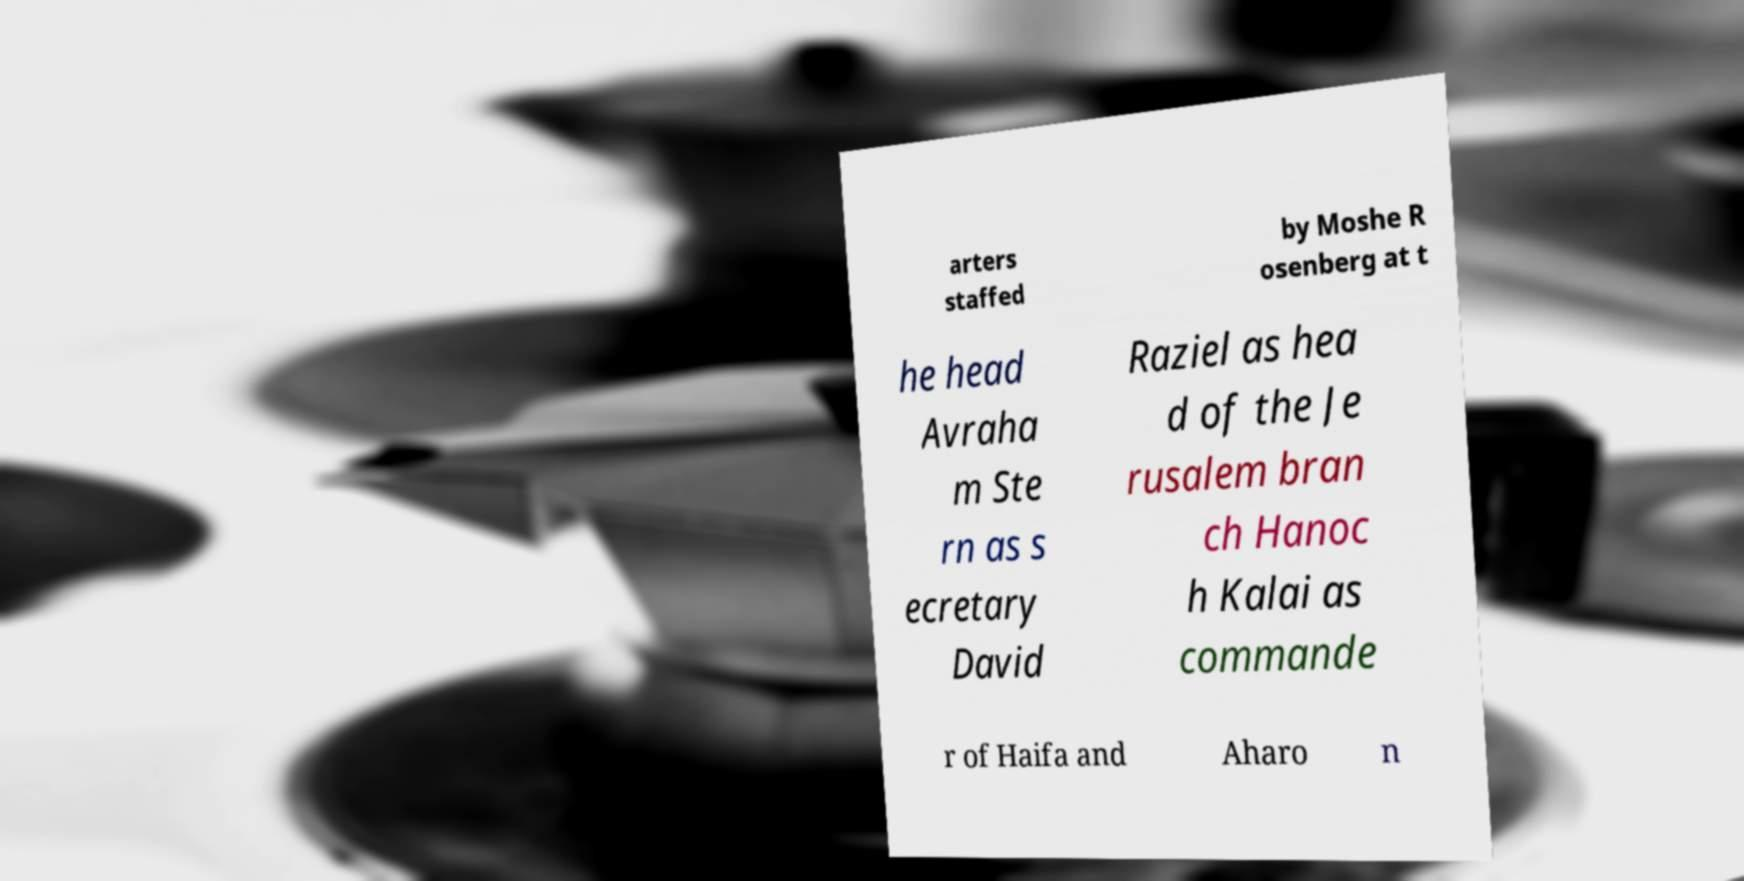What messages or text are displayed in this image? I need them in a readable, typed format. arters staffed by Moshe R osenberg at t he head Avraha m Ste rn as s ecretary David Raziel as hea d of the Je rusalem bran ch Hanoc h Kalai as commande r of Haifa and Aharo n 